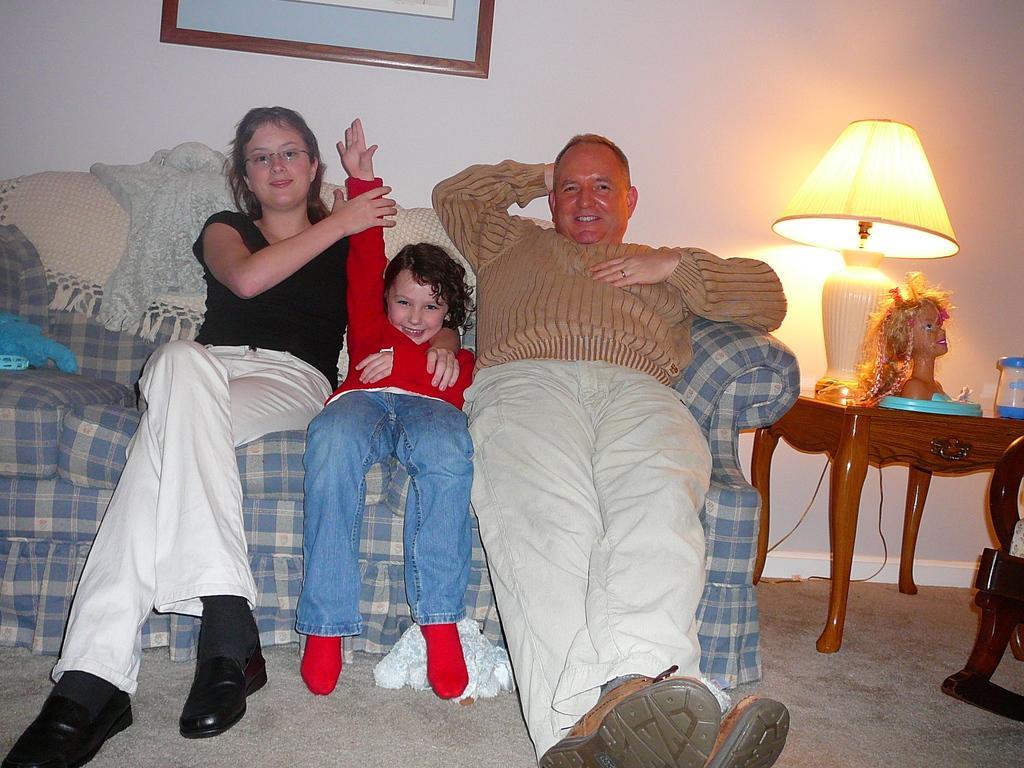In one or two sentences, can you explain what this image depicts? In this image there are three persons sitting on the blue and white colored sofa. The left corner woman is wearing a black t shirt and a white jeans with black shoes on and in the middle there is a kid having a red shirt and blue jeans and red socks on and in the right corner of the picture a man who is wearing a brown colored sweater and white pant with brown shoes on. In the back ground there is a wall and a wall frame hanging on the wall and in the right corner there is a corner table, on corner table there is a lamp and a toy and beside the corner table there is a small chair and there is beautiful carpet on the floor. 